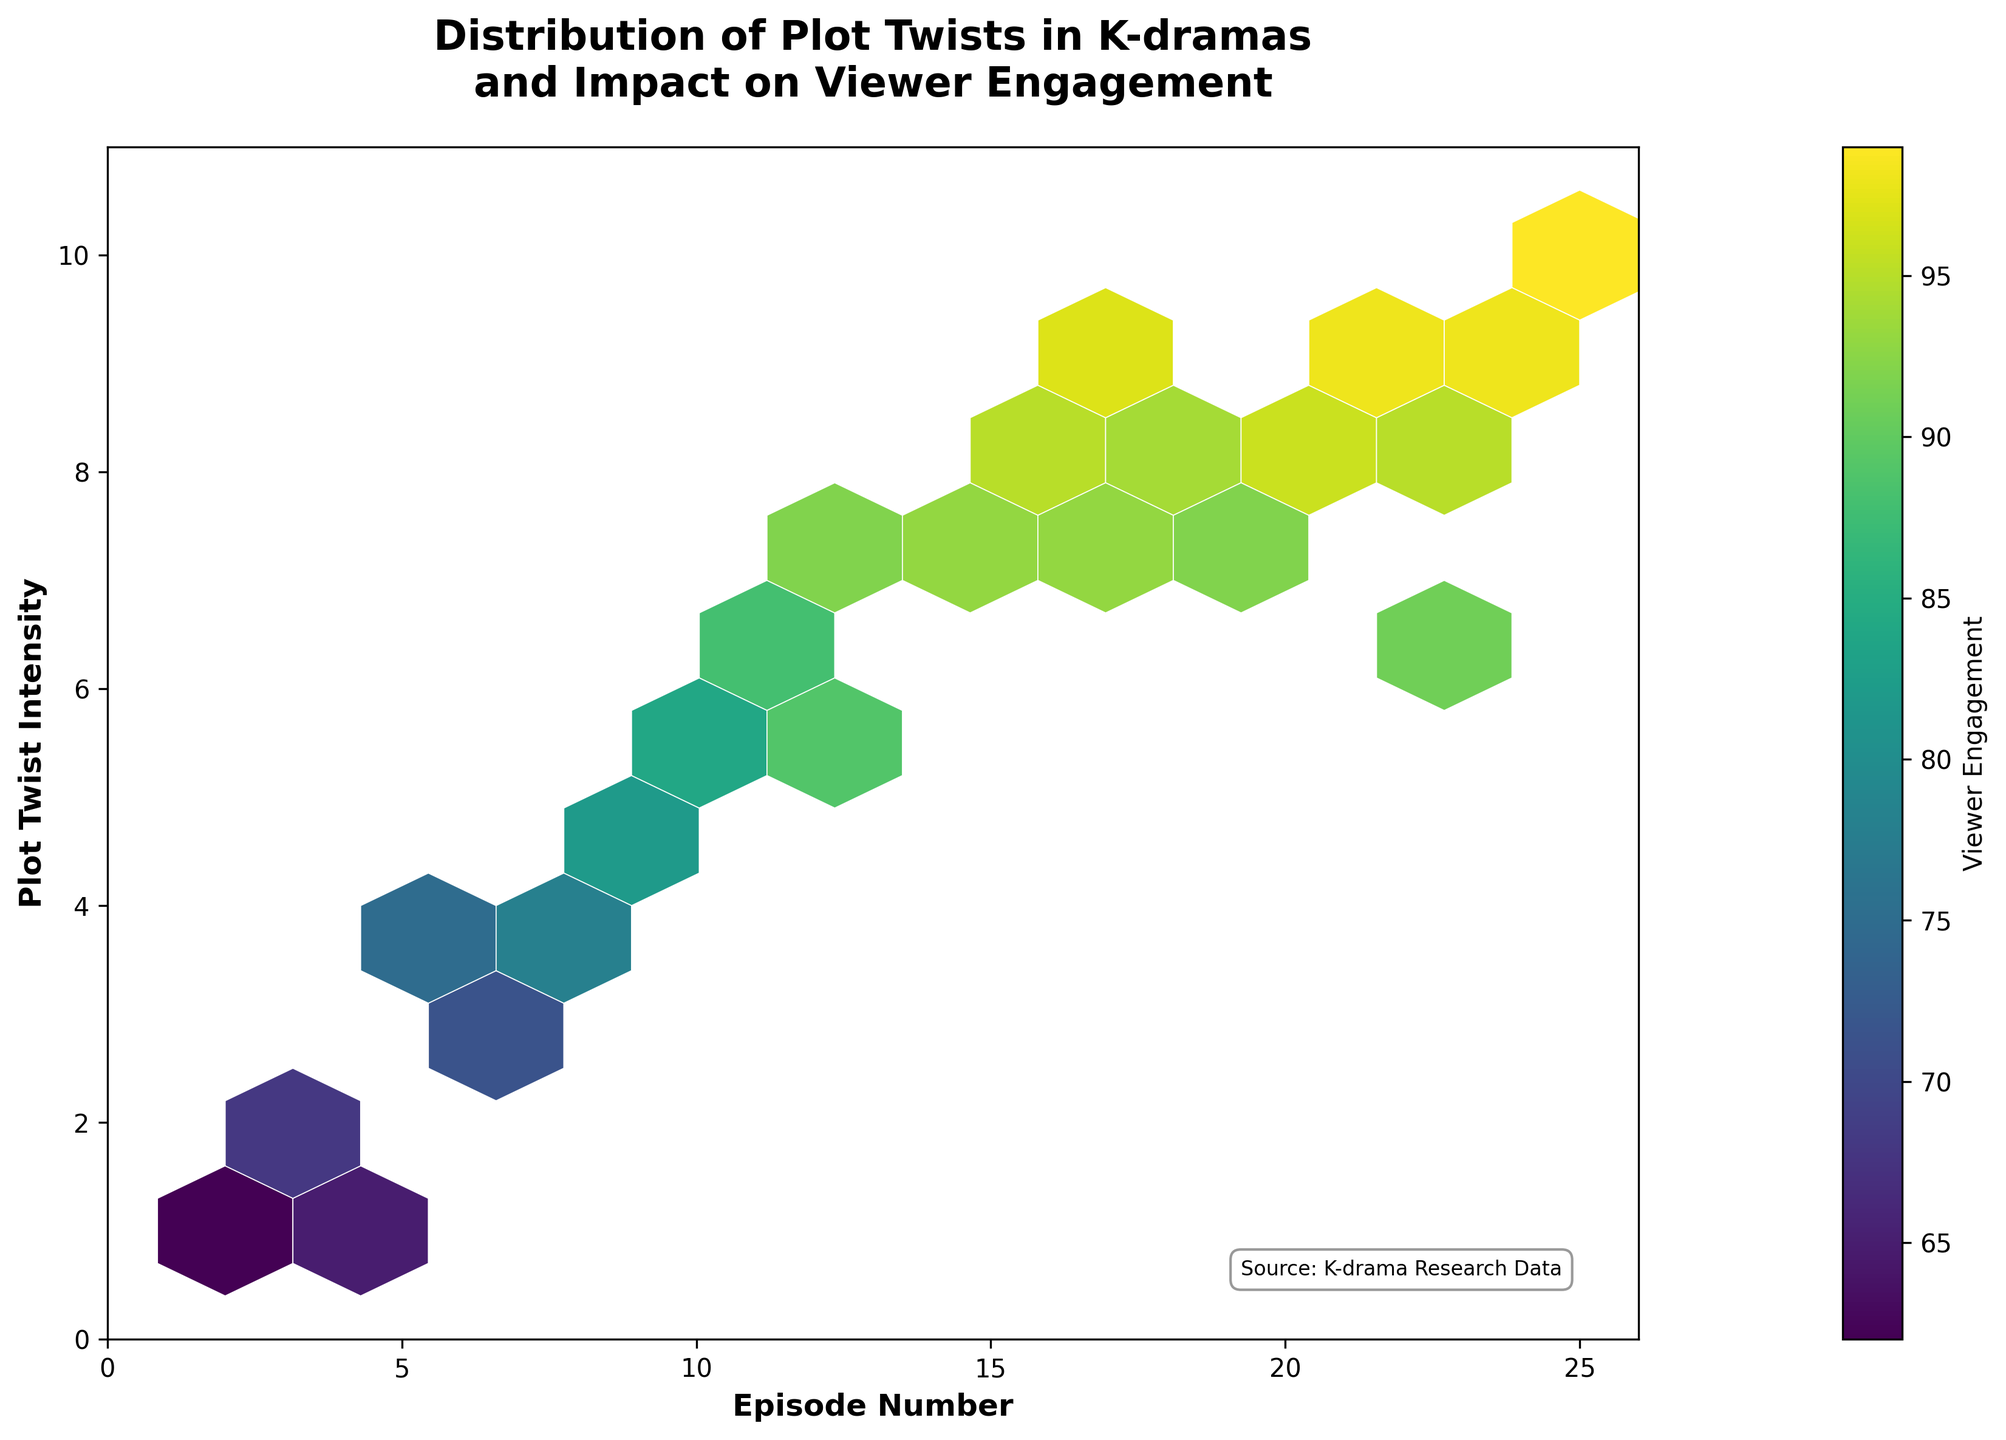How many episodes are visualized in the plot? The x-axis represents the episode numbers, and their range is from 1 to 25. It's a total of 25 unique episodes.
Answer: 25 What is the range of Plot Twist Intensity shown on the y-axis? The y-axis shows the Plot Twist Intensity ranging from 0 to 10. This range is evident from the axis labels and tick marks.
Answer: 0 to 10 Which episode has the highest viewer engagement? The color bar indicates viewer engagement, and the episode with Plot Twist Intensity of 10 (Episode 24) at the extreme right end of the plot, is linked with the highest viewer engagement.
Answer: Episode 24 Does viewer engagement generally increase or decrease with higher plot twist intensity? By observing the color gradient, it’s clear that the viewer engagement color intensifies as plot twist intensity increases.
Answer: Increase What plot twist intensity has the least viewer engagement, and what is the episode number? The plot shows lower engagement around Episode 2 and Episode 4, both having a Plot Twist Intensity of 1.
Answer: Intensity 1, Episodes 2 and 4 What is the average viewer engagement for episodes with a plot twist intensity of 7? Looking at the color hexes around intensity 7, episodes 13, 14, 18, and 19 correspond to engagement levels of 92, 93, 93, and 92 respectively. The average has to be calculated as follows: (92 + 93 + 93 + 92) / 4 = 370 / 4 = 92.5.
Answer: 92.5 Compare the viewer engagement between episodes 16 and 21. Which episode has a higher engagement? Episode 16 has a Plot Twist Intensity of 9 with Viewer Engagement around 97, whereas Episode 21 has the same intensity but Viewer Engagement is 98.
Answer: Episode 21 At what plot twist intensity does viewer engagement peak, and what is the engagement level? The most intense plot twist of 10 (from the color gradient indication) occurs at Episode 24, with the highest recorded viewer engagement of 99.
Answer: Intensity 10, Engagement 99 What is the distribution direction of plot twist intensity as the episodes progress? As episode numbers increase, plot twist intensity generally increases. This is observable from the scatter direction trending upwards along the episode axis.
Answer: Increasing 